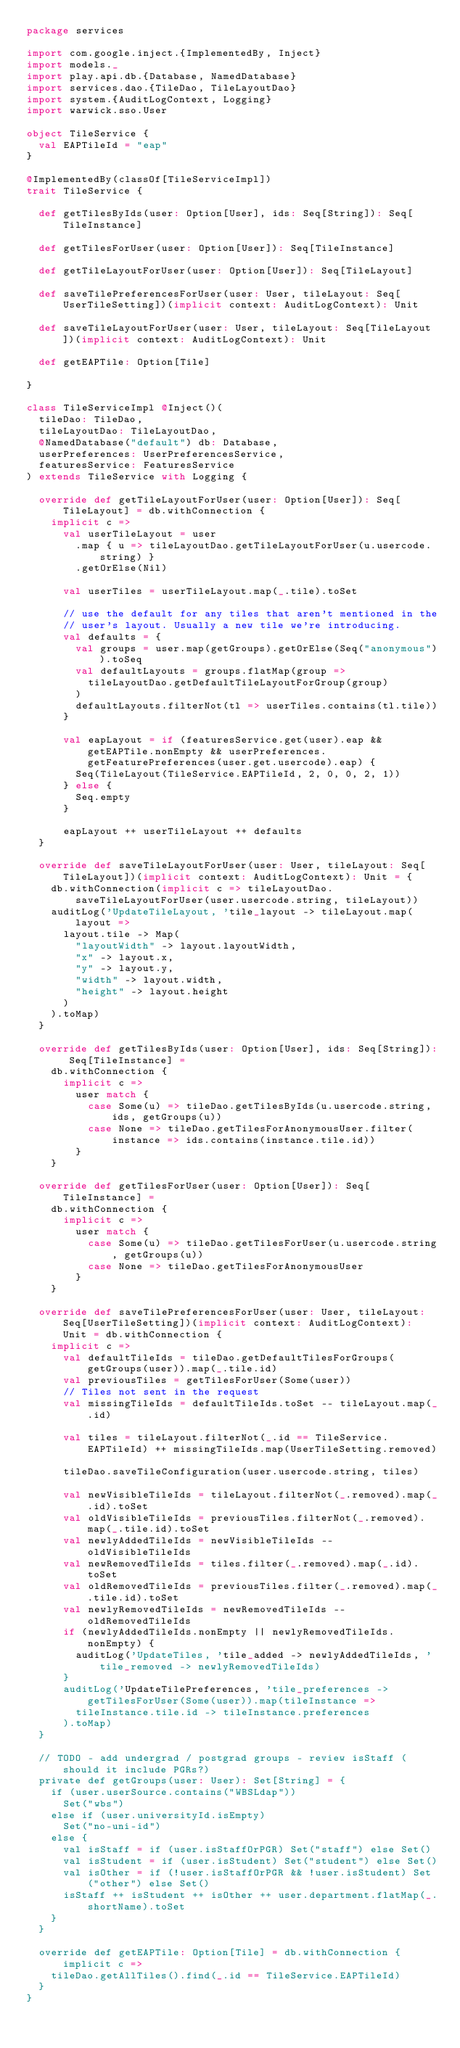<code> <loc_0><loc_0><loc_500><loc_500><_Scala_>package services

import com.google.inject.{ImplementedBy, Inject}
import models._
import play.api.db.{Database, NamedDatabase}
import services.dao.{TileDao, TileLayoutDao}
import system.{AuditLogContext, Logging}
import warwick.sso.User

object TileService {
  val EAPTileId = "eap"
}

@ImplementedBy(classOf[TileServiceImpl])
trait TileService {

  def getTilesByIds(user: Option[User], ids: Seq[String]): Seq[TileInstance]

  def getTilesForUser(user: Option[User]): Seq[TileInstance]

  def getTileLayoutForUser(user: Option[User]): Seq[TileLayout]

  def saveTilePreferencesForUser(user: User, tileLayout: Seq[UserTileSetting])(implicit context: AuditLogContext): Unit

  def saveTileLayoutForUser(user: User, tileLayout: Seq[TileLayout])(implicit context: AuditLogContext): Unit

  def getEAPTile: Option[Tile]

}

class TileServiceImpl @Inject()(
  tileDao: TileDao,
  tileLayoutDao: TileLayoutDao,
  @NamedDatabase("default") db: Database,
  userPreferences: UserPreferencesService,
  featuresService: FeaturesService
) extends TileService with Logging {

  override def getTileLayoutForUser(user: Option[User]): Seq[TileLayout] = db.withConnection {
    implicit c =>
      val userTileLayout = user
        .map { u => tileLayoutDao.getTileLayoutForUser(u.usercode.string) }
        .getOrElse(Nil)

      val userTiles = userTileLayout.map(_.tile).toSet

      // use the default for any tiles that aren't mentioned in the
      // user's layout. Usually a new tile we're introducing.
      val defaults = {
        val groups = user.map(getGroups).getOrElse(Seq("anonymous")).toSeq
        val defaultLayouts = groups.flatMap(group =>
          tileLayoutDao.getDefaultTileLayoutForGroup(group)
        )
        defaultLayouts.filterNot(tl => userTiles.contains(tl.tile))
      }

      val eapLayout = if (featuresService.get(user).eap && getEAPTile.nonEmpty && userPreferences.getFeaturePreferences(user.get.usercode).eap) {
        Seq(TileLayout(TileService.EAPTileId, 2, 0, 0, 2, 1))
      } else {
        Seq.empty
      }

      eapLayout ++ userTileLayout ++ defaults
  }

  override def saveTileLayoutForUser(user: User, tileLayout: Seq[TileLayout])(implicit context: AuditLogContext): Unit = {
    db.withConnection(implicit c => tileLayoutDao.saveTileLayoutForUser(user.usercode.string, tileLayout))
    auditLog('UpdateTileLayout, 'tile_layout -> tileLayout.map(layout =>
      layout.tile -> Map(
        "layoutWidth" -> layout.layoutWidth,
        "x" -> layout.x,
        "y" -> layout.y,
        "width" -> layout.width,
        "height" -> layout.height
      )
    ).toMap)
  }

  override def getTilesByIds(user: Option[User], ids: Seq[String]): Seq[TileInstance] =
    db.withConnection {
      implicit c =>
        user match {
          case Some(u) => tileDao.getTilesByIds(u.usercode.string, ids, getGroups(u))
          case None => tileDao.getTilesForAnonymousUser.filter(instance => ids.contains(instance.tile.id))
        }
    }

  override def getTilesForUser(user: Option[User]): Seq[TileInstance] =
    db.withConnection {
      implicit c =>
        user match {
          case Some(u) => tileDao.getTilesForUser(u.usercode.string, getGroups(u))
          case None => tileDao.getTilesForAnonymousUser
        }
    }

  override def saveTilePreferencesForUser(user: User, tileLayout: Seq[UserTileSetting])(implicit context: AuditLogContext): Unit = db.withConnection {
    implicit c =>
      val defaultTileIds = tileDao.getDefaultTilesForGroups(getGroups(user)).map(_.tile.id)
      val previousTiles = getTilesForUser(Some(user))
      // Tiles not sent in the request
      val missingTileIds = defaultTileIds.toSet -- tileLayout.map(_.id)

      val tiles = tileLayout.filterNot(_.id == TileService.EAPTileId) ++ missingTileIds.map(UserTileSetting.removed)

      tileDao.saveTileConfiguration(user.usercode.string, tiles)

      val newVisibleTileIds = tileLayout.filterNot(_.removed).map(_.id).toSet
      val oldVisibleTileIds = previousTiles.filterNot(_.removed).map(_.tile.id).toSet
      val newlyAddedTileIds = newVisibleTileIds -- oldVisibleTileIds
      val newRemovedTileIds = tiles.filter(_.removed).map(_.id).toSet
      val oldRemovedTileIds = previousTiles.filter(_.removed).map(_.tile.id).toSet
      val newlyRemovedTileIds = newRemovedTileIds -- oldRemovedTileIds
      if (newlyAddedTileIds.nonEmpty || newlyRemovedTileIds.nonEmpty) {
        auditLog('UpdateTiles, 'tile_added -> newlyAddedTileIds, 'tile_removed -> newlyRemovedTileIds)
      }
      auditLog('UpdateTilePreferences, 'tile_preferences -> getTilesForUser(Some(user)).map(tileInstance =>
        tileInstance.tile.id -> tileInstance.preferences
      ).toMap)
  }

  // TODO - add undergrad / postgrad groups - review isStaff (should it include PGRs?)
  private def getGroups(user: User): Set[String] = {
    if (user.userSource.contains("WBSLdap"))
      Set("wbs")
    else if (user.universityId.isEmpty)
      Set("no-uni-id")
    else {
      val isStaff = if (user.isStaffOrPGR) Set("staff") else Set()
      val isStudent = if (user.isStudent) Set("student") else Set()
      val isOther = if (!user.isStaffOrPGR && !user.isStudent) Set("other") else Set()
      isStaff ++ isStudent ++ isOther ++ user.department.flatMap(_.shortName).toSet
    }
  }

  override def getEAPTile: Option[Tile] = db.withConnection { implicit c =>
    tileDao.getAllTiles().find(_.id == TileService.EAPTileId)
  }
}
</code> 